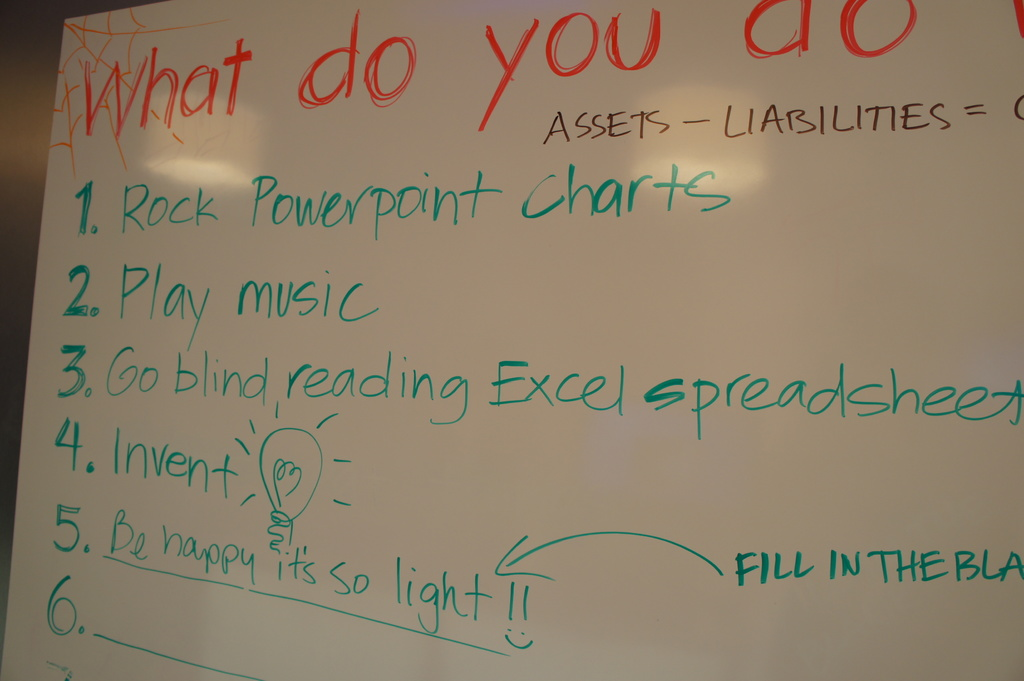How do the visual elements like color and handwriting impact the message conveyed by the whiteboard? The varied colors and casual handwriting style contribute to a relaxed and accessible atmosphere, underscoring the creative and informal tone of the board's message, which likely aims to inspire brainstorming and make idea-sharing feel more inclusive. 